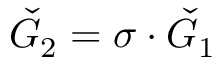Convert formula to latex. <formula><loc_0><loc_0><loc_500><loc_500>\check { G } _ { 2 } = \sigma \cdot \check { G } _ { 1 }</formula> 